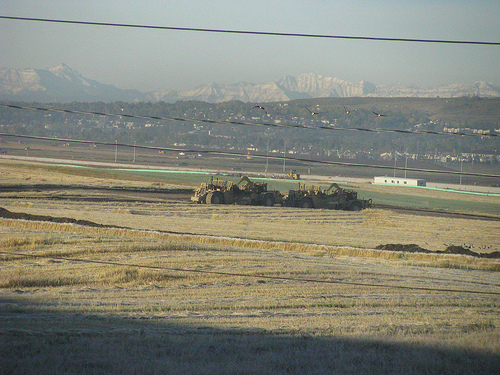<image>
Can you confirm if the mountains is above the truck? Yes. The mountains is positioned above the truck in the vertical space, higher up in the scene. 